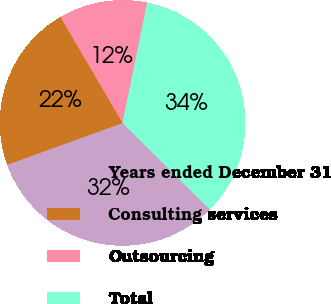<chart> <loc_0><loc_0><loc_500><loc_500><pie_chart><fcel>Years ended December 31<fcel>Consulting services<fcel>Outsourcing<fcel>Total<nl><fcel>32.03%<fcel>22.1%<fcel>11.65%<fcel>34.22%<nl></chart> 